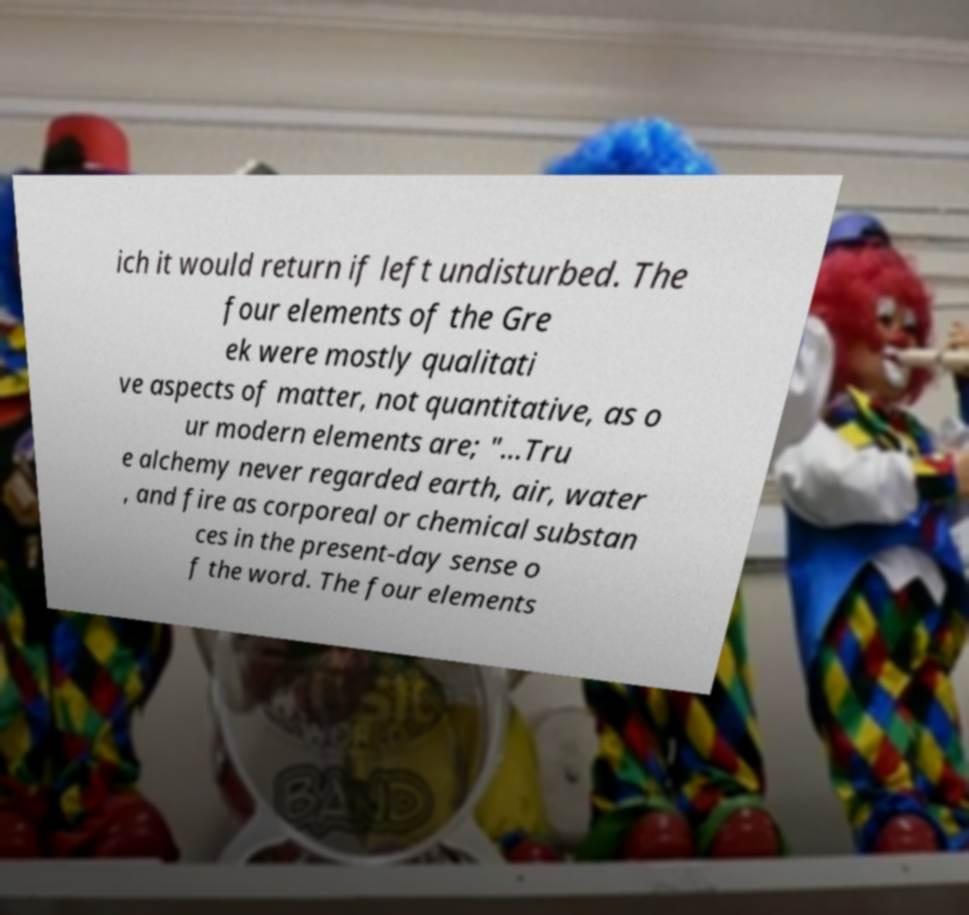Please identify and transcribe the text found in this image. ich it would return if left undisturbed. The four elements of the Gre ek were mostly qualitati ve aspects of matter, not quantitative, as o ur modern elements are; "...Tru e alchemy never regarded earth, air, water , and fire as corporeal or chemical substan ces in the present-day sense o f the word. The four elements 